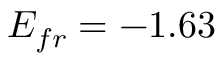Convert formula to latex. <formula><loc_0><loc_0><loc_500><loc_500>E _ { f r } = - 1 . 6 3</formula> 